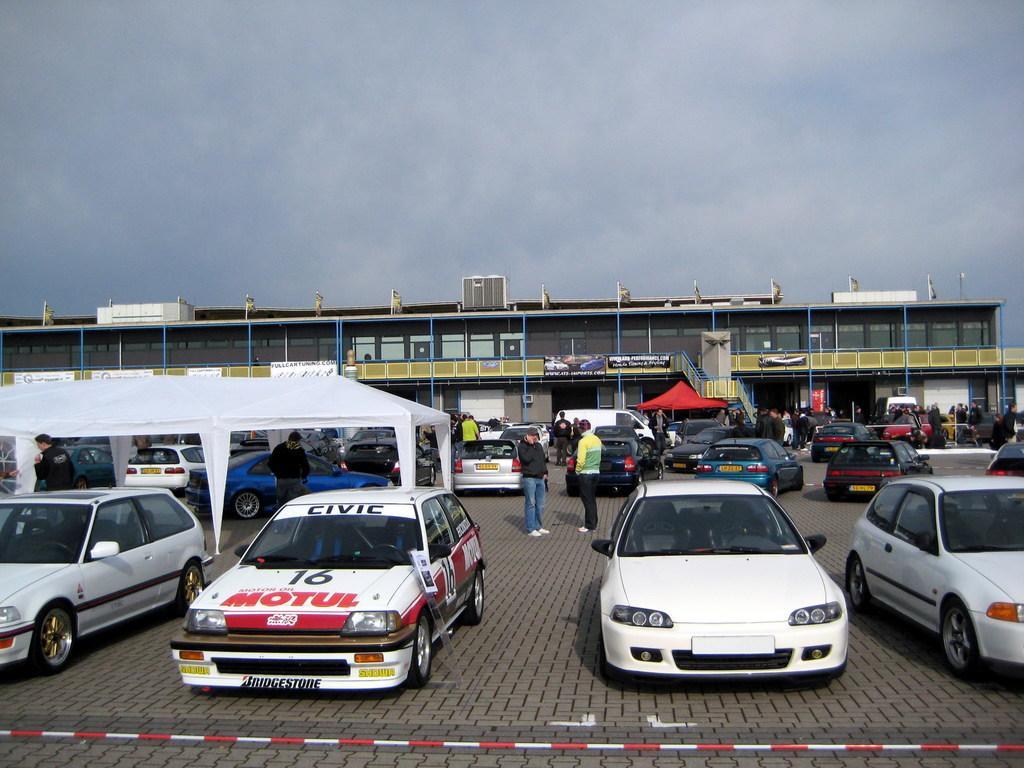Can you describe this image briefly? In this picture there is a there are some cars parked in the front. Behind there is a glass cars showroom with red and white color canopy sheds. 